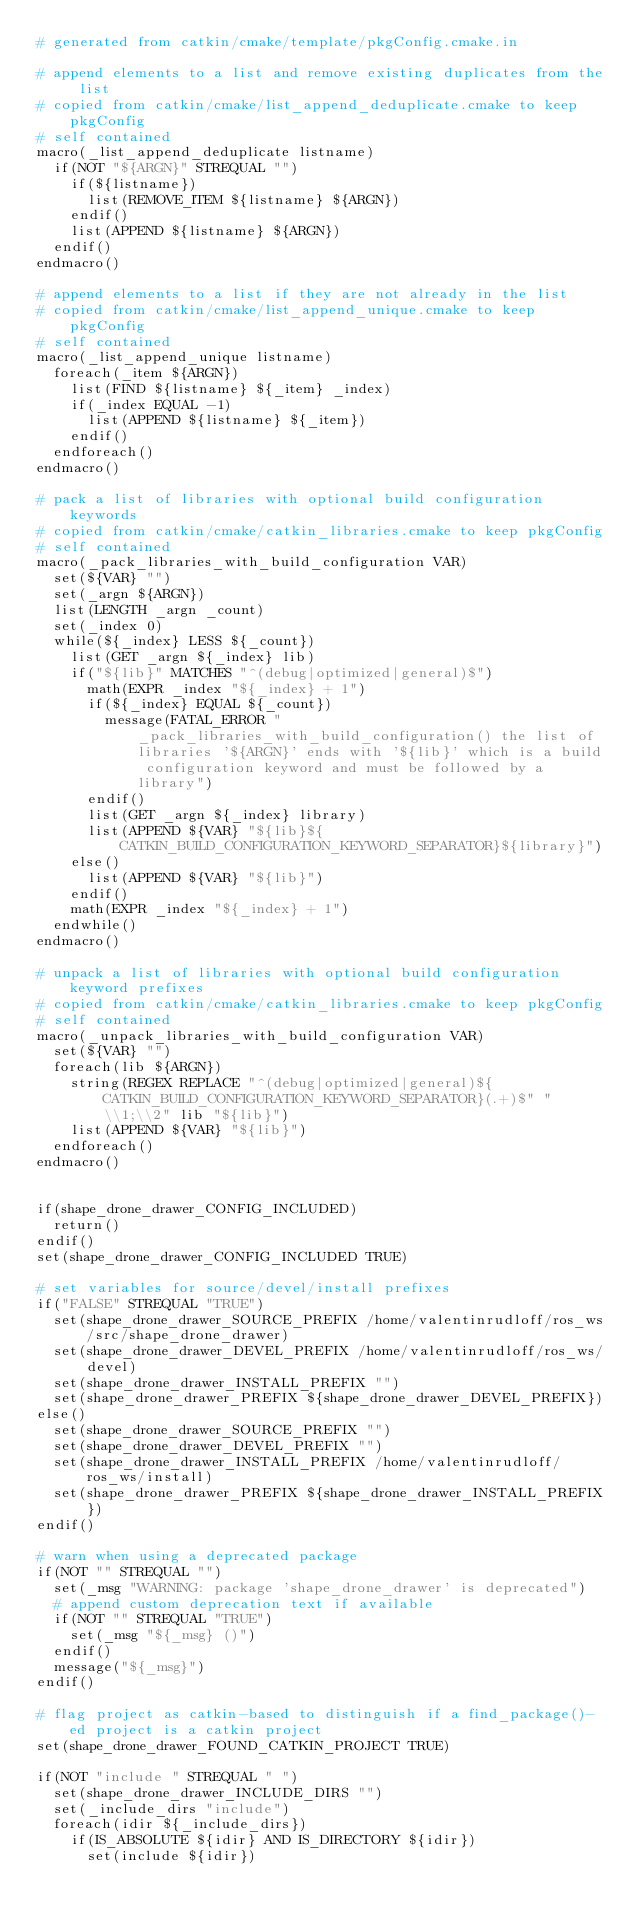Convert code to text. <code><loc_0><loc_0><loc_500><loc_500><_CMake_># generated from catkin/cmake/template/pkgConfig.cmake.in

# append elements to a list and remove existing duplicates from the list
# copied from catkin/cmake/list_append_deduplicate.cmake to keep pkgConfig
# self contained
macro(_list_append_deduplicate listname)
  if(NOT "${ARGN}" STREQUAL "")
    if(${listname})
      list(REMOVE_ITEM ${listname} ${ARGN})
    endif()
    list(APPEND ${listname} ${ARGN})
  endif()
endmacro()

# append elements to a list if they are not already in the list
# copied from catkin/cmake/list_append_unique.cmake to keep pkgConfig
# self contained
macro(_list_append_unique listname)
  foreach(_item ${ARGN})
    list(FIND ${listname} ${_item} _index)
    if(_index EQUAL -1)
      list(APPEND ${listname} ${_item})
    endif()
  endforeach()
endmacro()

# pack a list of libraries with optional build configuration keywords
# copied from catkin/cmake/catkin_libraries.cmake to keep pkgConfig
# self contained
macro(_pack_libraries_with_build_configuration VAR)
  set(${VAR} "")
  set(_argn ${ARGN})
  list(LENGTH _argn _count)
  set(_index 0)
  while(${_index} LESS ${_count})
    list(GET _argn ${_index} lib)
    if("${lib}" MATCHES "^(debug|optimized|general)$")
      math(EXPR _index "${_index} + 1")
      if(${_index} EQUAL ${_count})
        message(FATAL_ERROR "_pack_libraries_with_build_configuration() the list of libraries '${ARGN}' ends with '${lib}' which is a build configuration keyword and must be followed by a library")
      endif()
      list(GET _argn ${_index} library)
      list(APPEND ${VAR} "${lib}${CATKIN_BUILD_CONFIGURATION_KEYWORD_SEPARATOR}${library}")
    else()
      list(APPEND ${VAR} "${lib}")
    endif()
    math(EXPR _index "${_index} + 1")
  endwhile()
endmacro()

# unpack a list of libraries with optional build configuration keyword prefixes
# copied from catkin/cmake/catkin_libraries.cmake to keep pkgConfig
# self contained
macro(_unpack_libraries_with_build_configuration VAR)
  set(${VAR} "")
  foreach(lib ${ARGN})
    string(REGEX REPLACE "^(debug|optimized|general)${CATKIN_BUILD_CONFIGURATION_KEYWORD_SEPARATOR}(.+)$" "\\1;\\2" lib "${lib}")
    list(APPEND ${VAR} "${lib}")
  endforeach()
endmacro()


if(shape_drone_drawer_CONFIG_INCLUDED)
  return()
endif()
set(shape_drone_drawer_CONFIG_INCLUDED TRUE)

# set variables for source/devel/install prefixes
if("FALSE" STREQUAL "TRUE")
  set(shape_drone_drawer_SOURCE_PREFIX /home/valentinrudloff/ros_ws/src/shape_drone_drawer)
  set(shape_drone_drawer_DEVEL_PREFIX /home/valentinrudloff/ros_ws/devel)
  set(shape_drone_drawer_INSTALL_PREFIX "")
  set(shape_drone_drawer_PREFIX ${shape_drone_drawer_DEVEL_PREFIX})
else()
  set(shape_drone_drawer_SOURCE_PREFIX "")
  set(shape_drone_drawer_DEVEL_PREFIX "")
  set(shape_drone_drawer_INSTALL_PREFIX /home/valentinrudloff/ros_ws/install)
  set(shape_drone_drawer_PREFIX ${shape_drone_drawer_INSTALL_PREFIX})
endif()

# warn when using a deprecated package
if(NOT "" STREQUAL "")
  set(_msg "WARNING: package 'shape_drone_drawer' is deprecated")
  # append custom deprecation text if available
  if(NOT "" STREQUAL "TRUE")
    set(_msg "${_msg} ()")
  endif()
  message("${_msg}")
endif()

# flag project as catkin-based to distinguish if a find_package()-ed project is a catkin project
set(shape_drone_drawer_FOUND_CATKIN_PROJECT TRUE)

if(NOT "include " STREQUAL " ")
  set(shape_drone_drawer_INCLUDE_DIRS "")
  set(_include_dirs "include")
  foreach(idir ${_include_dirs})
    if(IS_ABSOLUTE ${idir} AND IS_DIRECTORY ${idir})
      set(include ${idir})</code> 